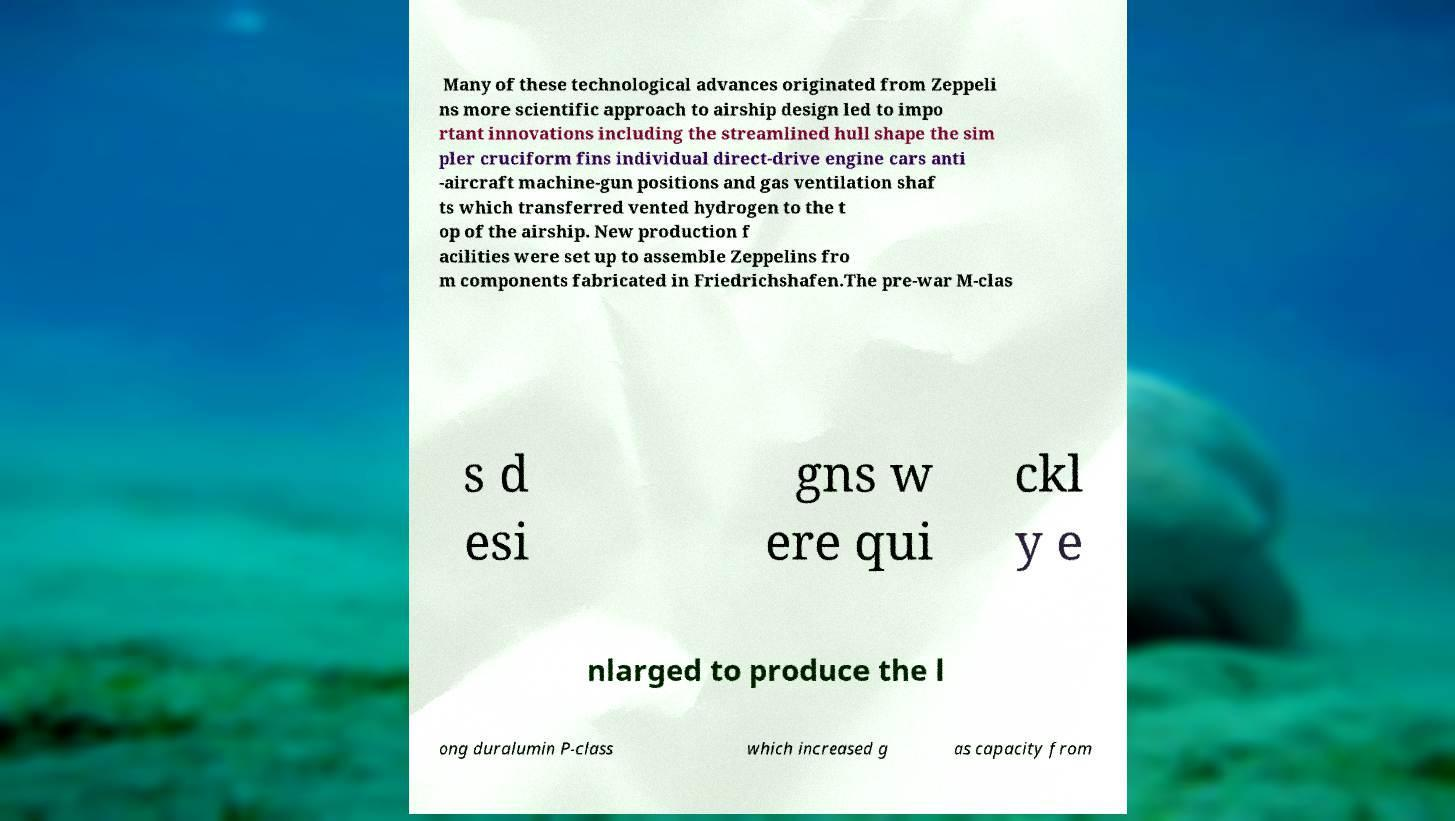Could you extract and type out the text from this image? Many of these technological advances originated from Zeppeli ns more scientific approach to airship design led to impo rtant innovations including the streamlined hull shape the sim pler cruciform fins individual direct-drive engine cars anti -aircraft machine-gun positions and gas ventilation shaf ts which transferred vented hydrogen to the t op of the airship. New production f acilities were set up to assemble Zeppelins fro m components fabricated in Friedrichshafen.The pre-war M-clas s d esi gns w ere qui ckl y e nlarged to produce the l ong duralumin P-class which increased g as capacity from 